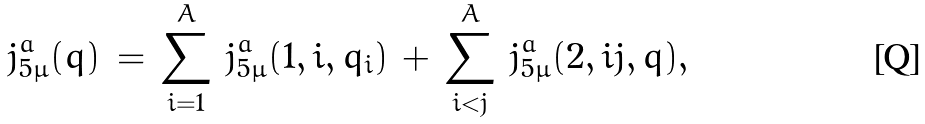<formula> <loc_0><loc_0><loc_500><loc_500>j ^ { a } _ { 5 \mu } ( q ) \, = \, \sum ^ { A } _ { i = 1 } \, j ^ { a } _ { 5 \mu } ( 1 , i , q _ { i } ) \, + \, \sum ^ { A } _ { i < j } \, j ^ { a } _ { 5 \mu } ( 2 , i j , q ) ,</formula> 